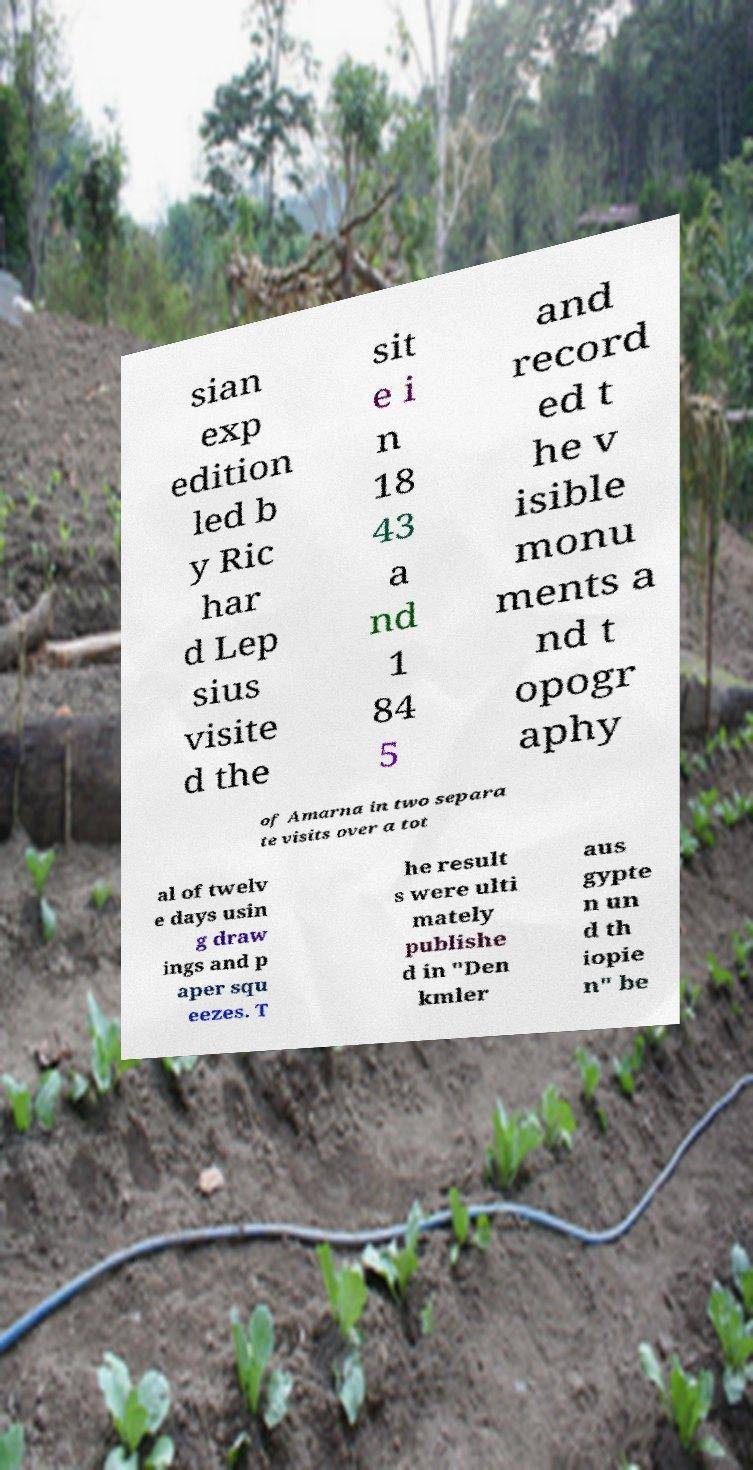Can you read and provide the text displayed in the image?This photo seems to have some interesting text. Can you extract and type it out for me? sian exp edition led b y Ric har d Lep sius visite d the sit e i n 18 43 a nd 1 84 5 and record ed t he v isible monu ments a nd t opogr aphy of Amarna in two separa te visits over a tot al of twelv e days usin g draw ings and p aper squ eezes. T he result s were ulti mately publishe d in "Den kmler aus gypte n un d th iopie n" be 